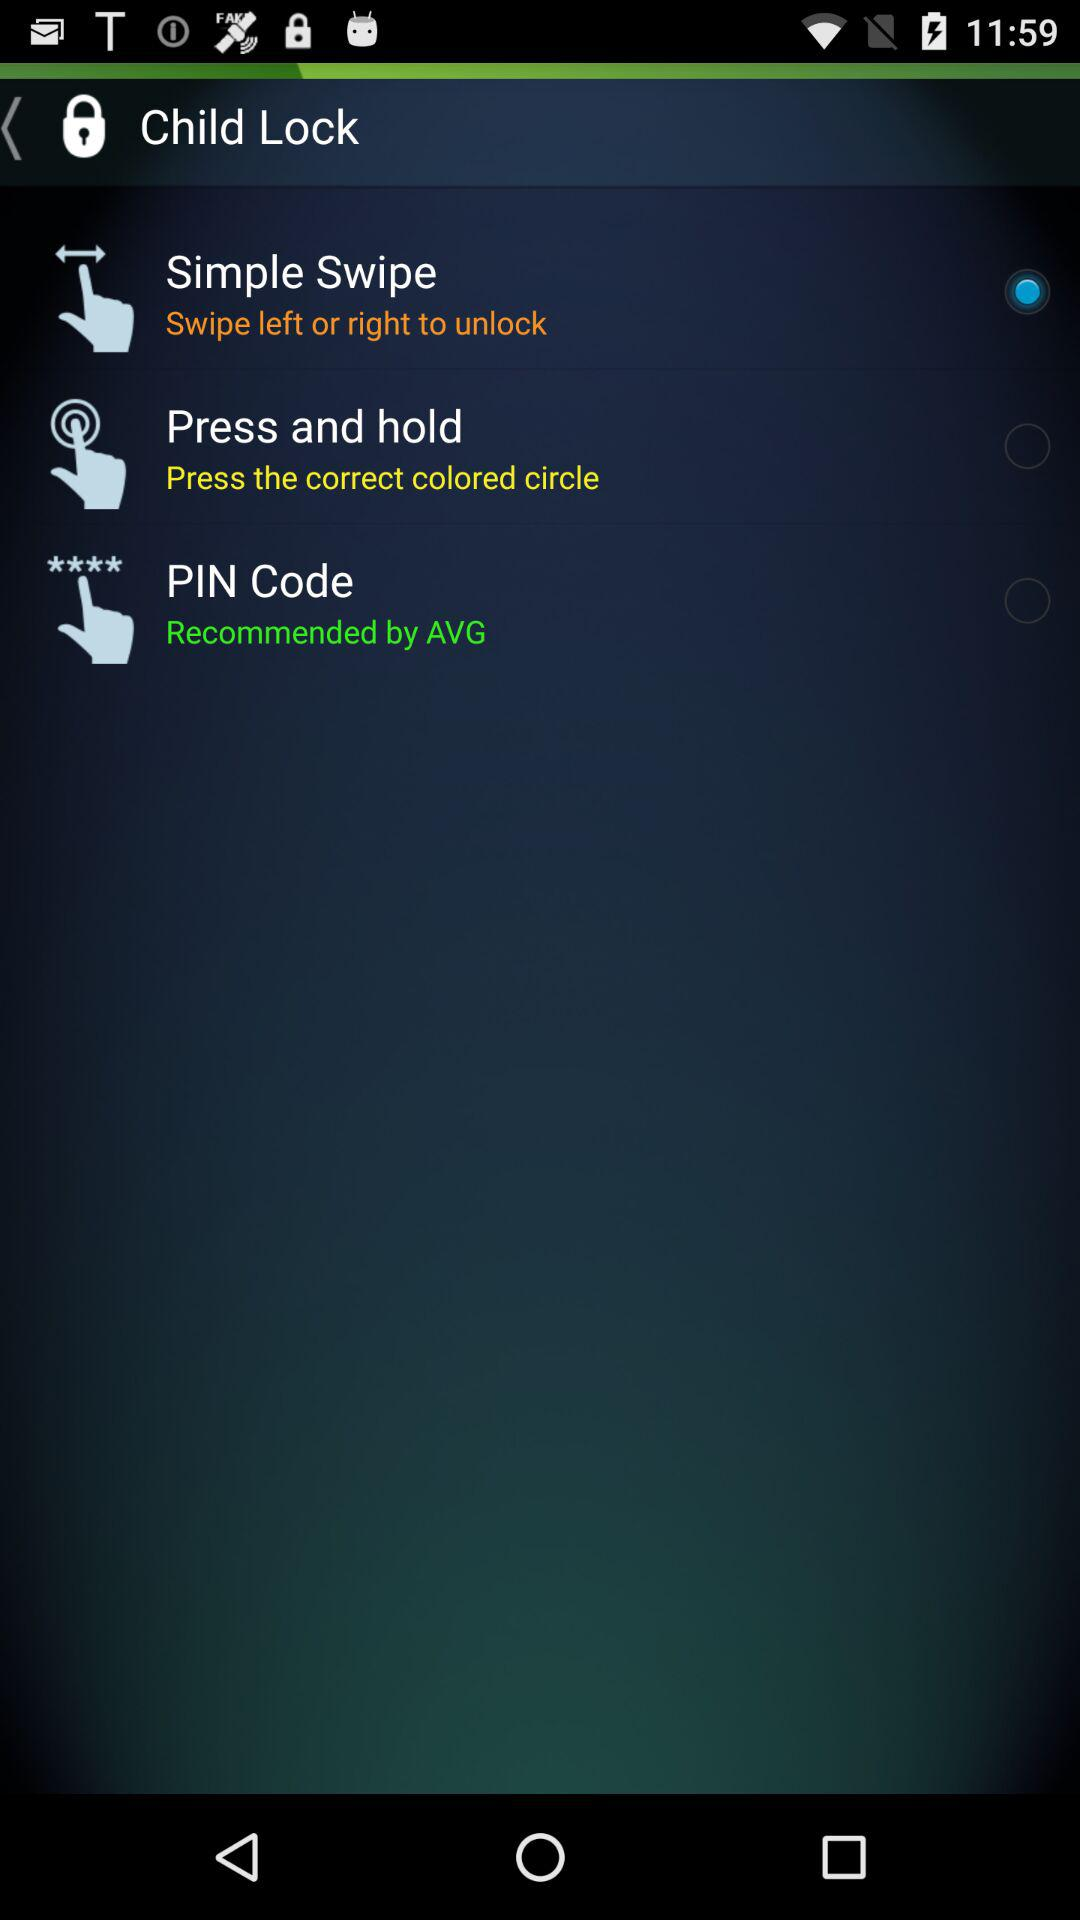Is the "Simple Swipe" setting selected or not? The "Simple Swipe" setting is selected. 